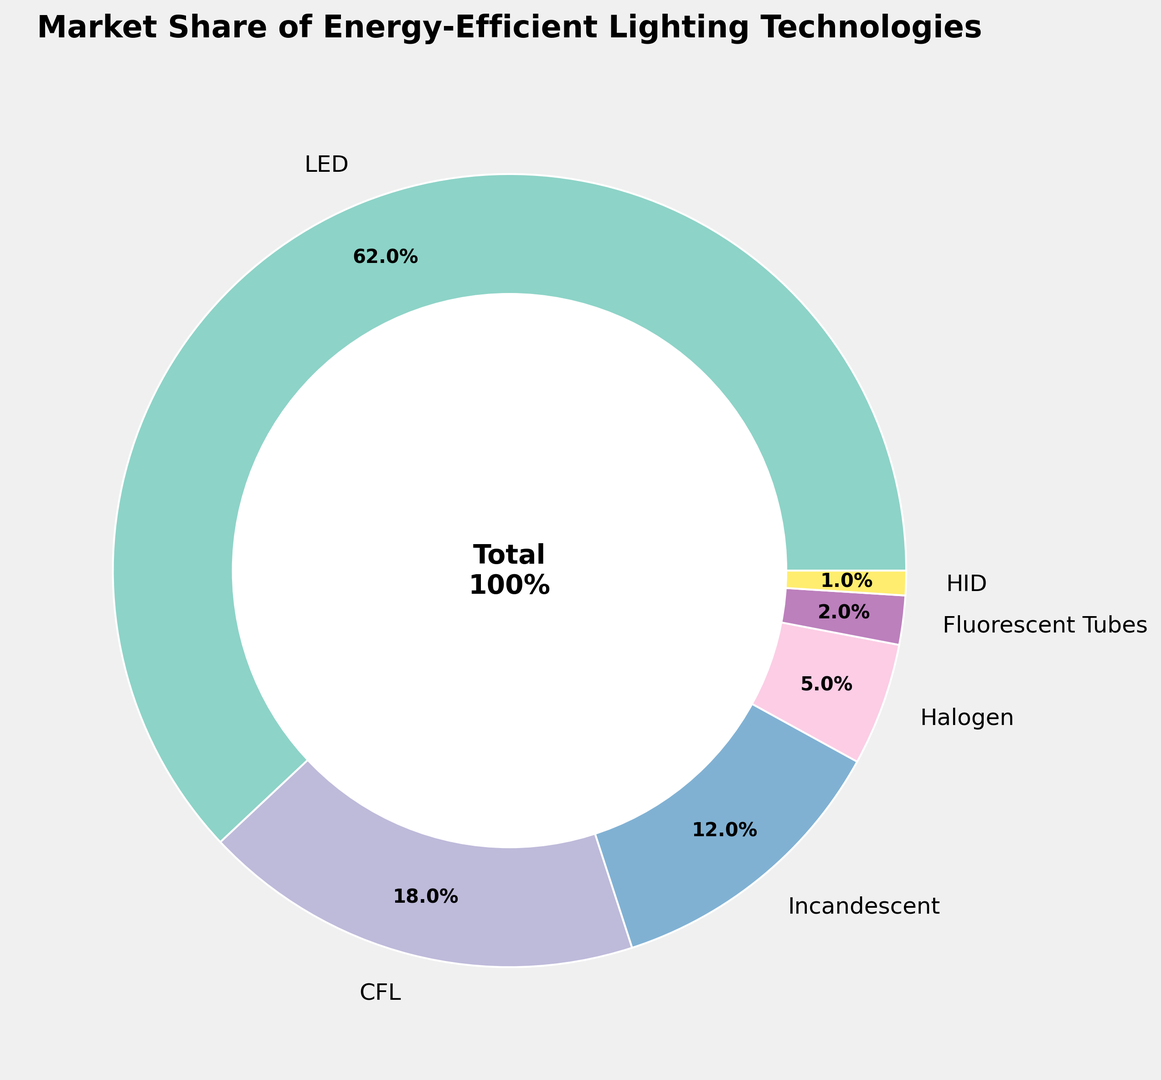What is the market share of LED technology? The figure shows the market share of different lighting technologies with LED having a large portion. The market share for LED is labeled directly on the ring chart.
Answer: 62% Which technology has the smallest market share? Among the segments, the smallest slice is labeled with "HID," which indicates this technology has the smallest market share.
Answer: HID How much larger is the market share of LED compared to traditional incandescent bulbs? The market share for LED is 62% and for incandescent bulbs is 12%. Subtract the smaller from the larger: 62% - 12% = 50%.
Answer: 50% Combine the market shares of CFL and Halogen bulbs. What is their total market share? CFL has an 18% share and Halogen has a 5% share. Adding them together: 18% + 5% = 23%.
Answer: 23% Which two technologies have nearly the same market share, and what are their values? The segments for Fluorescent Tubes and HID are visually close in size. Fluorescent Tubes have a 2% market share and HID has 1%.
Answer: Fluorescent Tubes and HID, 2% and 1% How does the market share of CFL compare to that of Incandescent bulbs? CFL shares 18% of the market while Incandescent shows a 12% share. CFL’s market share is 6% higher than Incandescent's.
Answer: CFL market share is 6% higher What percentage of the market is captured by technologies other than LED? Adding the market shares of all technologies except LED: 18% (CFL) + 12% (Incandescent) + 5% (Halogen) + 2% (Fluorescent Tubes) + 1% (HID) = 38%.
Answer: 38% What is the visual representation that shows that LED has the majority market share? The LED segment occupies the largest portion of the ring chart, labeled as 62%, which visually indicates the majority share.
Answer: Largest segment with 62% label What is indicated at the center of the ring chart? The center of the ring chart includes text that states 'Total 100%' indicating the whole pie represents 100% of the market share.
Answer: 'Total 100%' 